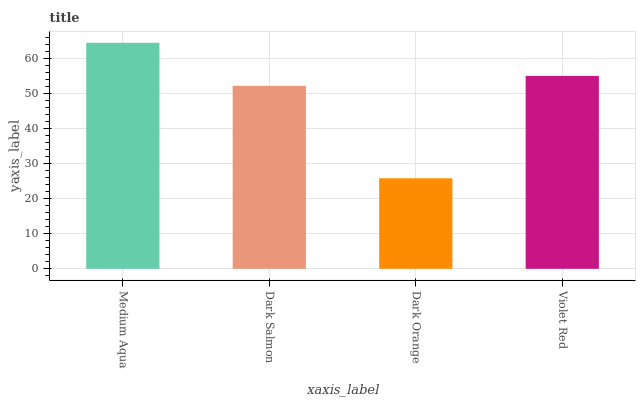Is Dark Salmon the minimum?
Answer yes or no. No. Is Dark Salmon the maximum?
Answer yes or no. No. Is Medium Aqua greater than Dark Salmon?
Answer yes or no. Yes. Is Dark Salmon less than Medium Aqua?
Answer yes or no. Yes. Is Dark Salmon greater than Medium Aqua?
Answer yes or no. No. Is Medium Aqua less than Dark Salmon?
Answer yes or no. No. Is Violet Red the high median?
Answer yes or no. Yes. Is Dark Salmon the low median?
Answer yes or no. Yes. Is Dark Orange the high median?
Answer yes or no. No. Is Medium Aqua the low median?
Answer yes or no. No. 